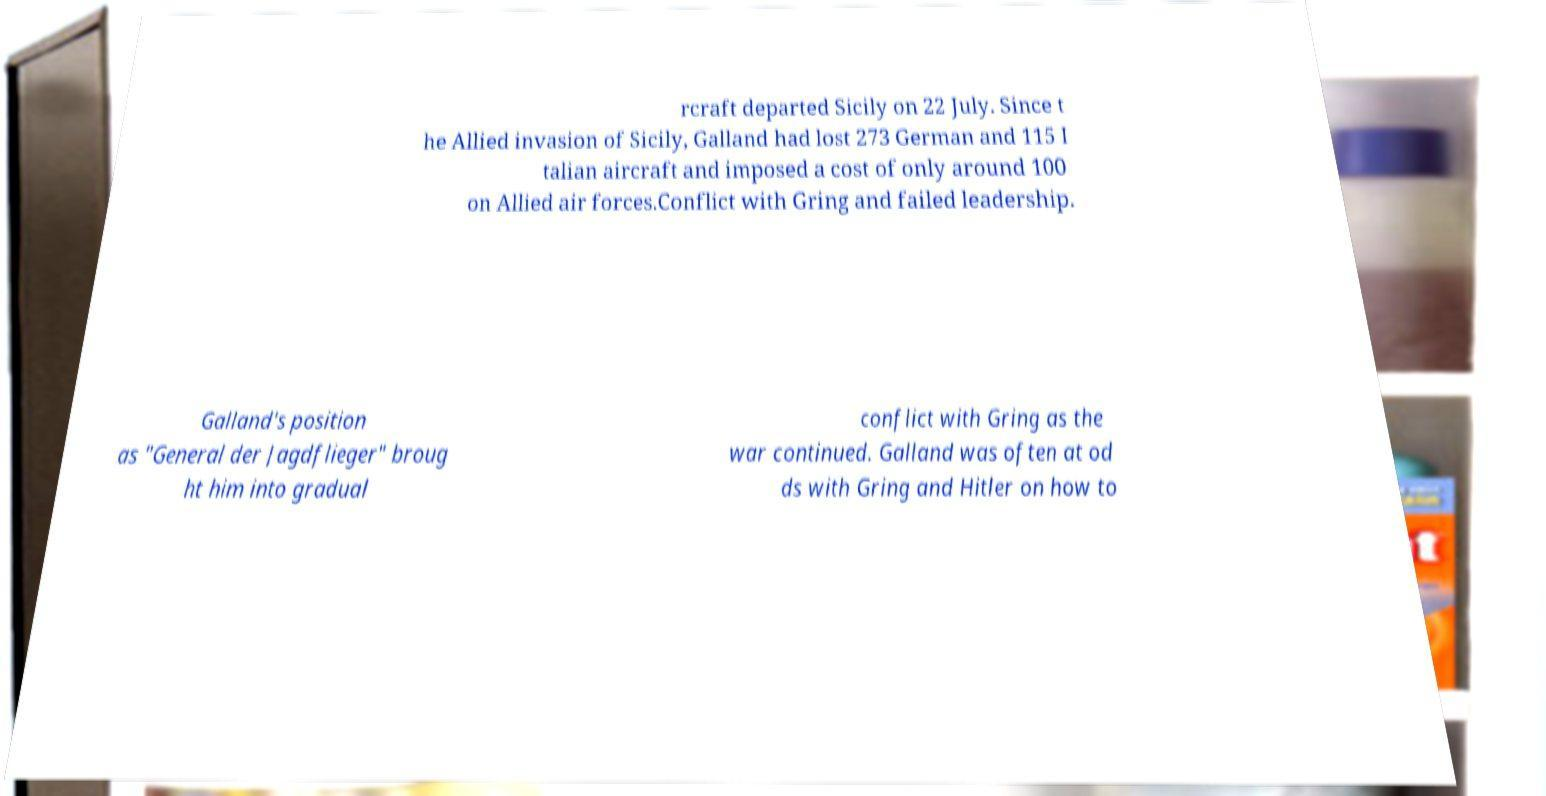Please identify and transcribe the text found in this image. rcraft departed Sicily on 22 July. Since t he Allied invasion of Sicily, Galland had lost 273 German and 115 I talian aircraft and imposed a cost of only around 100 on Allied air forces.Conflict with Gring and failed leadership. Galland's position as "General der Jagdflieger" broug ht him into gradual conflict with Gring as the war continued. Galland was often at od ds with Gring and Hitler on how to 